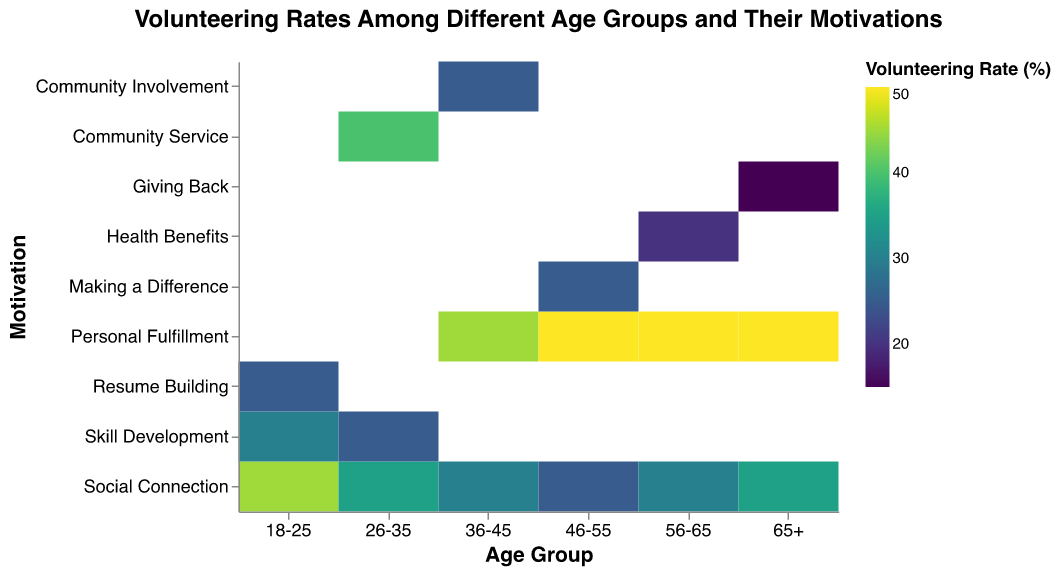What is the main title of the figure? The main title is located at the top center of the figure and reads "Volunteering Rates Among Different Age Groups and Their Motivations."
Answer: Volunteering Rates Among Different Age Groups and Their Motivations Which age group shows the highest volunteering rate for Social Connection? To find this, look for the cell with the highest color intensity in the Social Connection row. The highest value under Social Connection is 45%, which corresponds to the 18-25 age group.
Answer: 18-25 What is the volunteering rate for Skill Development in the 26-35 age group? Locate the intersection of the 26-35 age group column and the Skill Development row to find the volunteering rate. The rate is 25%.
Answer: 25% Which motivation has the highest volunteering rate across all age groups? By comparing the highest values in each row, Personal Fulfillment shows the highest rate of 50% across multiple age groups (46-55, 56-65, 65+).
Answer: Personal Fulfillment How does the volunteering rate for Personal Fulfillment compare between the 36-45 and 46-55 age groups? Compare the volunteering rates shown in the Personal Fulfillment row for both age groups. The rate is 45% for 36-45 and 50% for 46-55.
Answer: 46-55 has a higher rate What is the average volunteering rate for Social Connection across all age groups? Sum the Social Connection rates: 45% (18-25), 35% (26-35), 30% (36-45), 25% (46-55), 30% (56-65), 35% (65+). Total = 200%. There are 6 age groups. 200% / 6 = 33.33%
Answer: 33.33% Which age group has the lowest volunteering rate overall, and what is it? Identify the least intense cell. The lowest rate overall is in the 65+ age group for Giving Back, which is 15%.
Answer: 65+, 15% What trend can be observed about Personal Fulfillment rates across different age groups? Personal Fulfillment has high and similar rates (around 50%) across older age groups starting from 46-55 to 65+. The rate is slightly lower (45%) in the younger 36-45 age group.
Answer: High rates in older age groups Which age group's primary motivation appears to be Making a Difference? Look for the highest volunteering rate under Making a Difference. The only data point for this is a 25% rate in the 46-55 age group, indicating a significant focus.
Answer: 46-55 How many unique motivations are tracked in the heatmap? Count the different motivations listed in the y-axis. The unique motivations are Social Connection, Skill Development, Resume Building, Community Service, Personal Fulfillment, Community Involvement, Making a Difference, Health Benefits, and Giving Back, totaling 9.
Answer: 9 